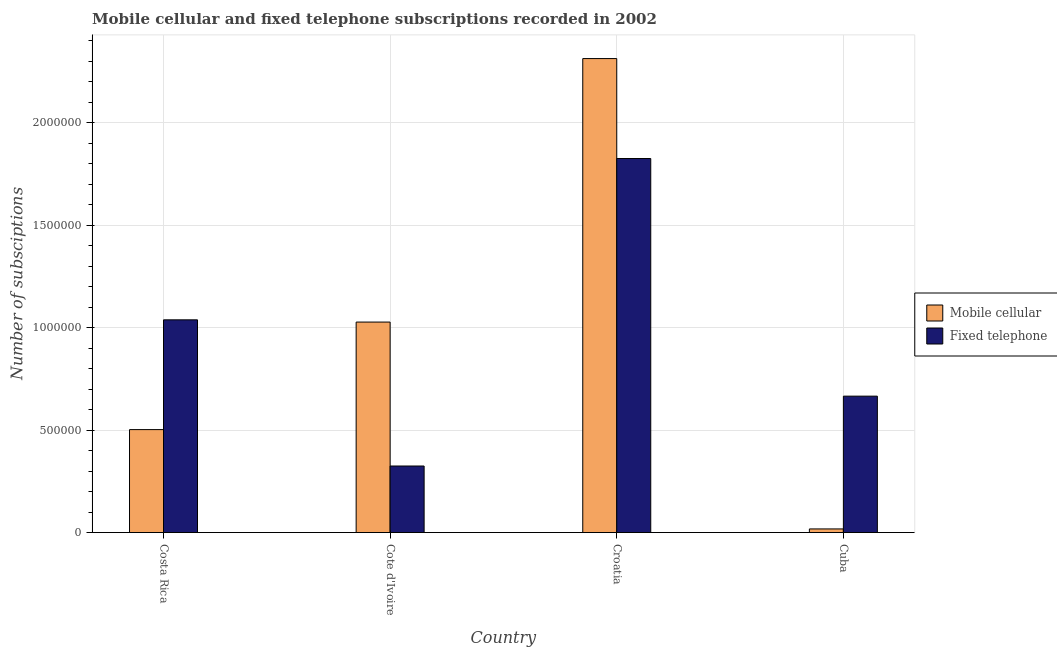How many different coloured bars are there?
Make the answer very short. 2. Are the number of bars per tick equal to the number of legend labels?
Provide a succinct answer. Yes. How many bars are there on the 4th tick from the left?
Offer a very short reply. 2. How many bars are there on the 3rd tick from the right?
Your answer should be very brief. 2. What is the label of the 1st group of bars from the left?
Provide a short and direct response. Costa Rica. In how many cases, is the number of bars for a given country not equal to the number of legend labels?
Offer a terse response. 0. What is the number of mobile cellular subscriptions in Croatia?
Give a very brief answer. 2.31e+06. Across all countries, what is the maximum number of fixed telephone subscriptions?
Provide a succinct answer. 1.82e+06. Across all countries, what is the minimum number of fixed telephone subscriptions?
Provide a short and direct response. 3.25e+05. In which country was the number of fixed telephone subscriptions maximum?
Offer a very short reply. Croatia. In which country was the number of mobile cellular subscriptions minimum?
Make the answer very short. Cuba. What is the total number of mobile cellular subscriptions in the graph?
Ensure brevity in your answer.  3.86e+06. What is the difference between the number of mobile cellular subscriptions in Cote d'Ivoire and that in Cuba?
Ensure brevity in your answer.  1.01e+06. What is the difference between the number of fixed telephone subscriptions in Cuba and the number of mobile cellular subscriptions in Cote d'Ivoire?
Keep it short and to the point. -3.61e+05. What is the average number of fixed telephone subscriptions per country?
Your response must be concise. 9.63e+05. What is the difference between the number of fixed telephone subscriptions and number of mobile cellular subscriptions in Costa Rica?
Give a very brief answer. 5.36e+05. What is the ratio of the number of fixed telephone subscriptions in Costa Rica to that in Croatia?
Your response must be concise. 0.57. Is the number of fixed telephone subscriptions in Costa Rica less than that in Cote d'Ivoire?
Give a very brief answer. No. Is the difference between the number of mobile cellular subscriptions in Cote d'Ivoire and Cuba greater than the difference between the number of fixed telephone subscriptions in Cote d'Ivoire and Cuba?
Your answer should be compact. Yes. What is the difference between the highest and the second highest number of fixed telephone subscriptions?
Give a very brief answer. 7.87e+05. What is the difference between the highest and the lowest number of mobile cellular subscriptions?
Provide a short and direct response. 2.29e+06. What does the 2nd bar from the left in Cote d'Ivoire represents?
Provide a short and direct response. Fixed telephone. What does the 1st bar from the right in Cuba represents?
Give a very brief answer. Fixed telephone. How many countries are there in the graph?
Offer a very short reply. 4. What is the difference between two consecutive major ticks on the Y-axis?
Give a very brief answer. 5.00e+05. Are the values on the major ticks of Y-axis written in scientific E-notation?
Offer a very short reply. No. Does the graph contain grids?
Provide a succinct answer. Yes. How many legend labels are there?
Make the answer very short. 2. How are the legend labels stacked?
Provide a short and direct response. Vertical. What is the title of the graph?
Ensure brevity in your answer.  Mobile cellular and fixed telephone subscriptions recorded in 2002. What is the label or title of the Y-axis?
Offer a terse response. Number of subsciptions. What is the Number of subsciptions in Mobile cellular in Costa Rica?
Your answer should be very brief. 5.02e+05. What is the Number of subsciptions in Fixed telephone in Costa Rica?
Provide a succinct answer. 1.04e+06. What is the Number of subsciptions of Mobile cellular in Cote d'Ivoire?
Keep it short and to the point. 1.03e+06. What is the Number of subsciptions of Fixed telephone in Cote d'Ivoire?
Your answer should be very brief. 3.25e+05. What is the Number of subsciptions in Mobile cellular in Croatia?
Give a very brief answer. 2.31e+06. What is the Number of subsciptions in Fixed telephone in Croatia?
Give a very brief answer. 1.82e+06. What is the Number of subsciptions in Mobile cellular in Cuba?
Provide a succinct answer. 1.79e+04. What is the Number of subsciptions of Fixed telephone in Cuba?
Your answer should be compact. 6.66e+05. Across all countries, what is the maximum Number of subsciptions of Mobile cellular?
Your answer should be very brief. 2.31e+06. Across all countries, what is the maximum Number of subsciptions of Fixed telephone?
Your answer should be compact. 1.82e+06. Across all countries, what is the minimum Number of subsciptions of Mobile cellular?
Your answer should be very brief. 1.79e+04. Across all countries, what is the minimum Number of subsciptions in Fixed telephone?
Your answer should be very brief. 3.25e+05. What is the total Number of subsciptions of Mobile cellular in the graph?
Provide a succinct answer. 3.86e+06. What is the total Number of subsciptions of Fixed telephone in the graph?
Give a very brief answer. 3.85e+06. What is the difference between the Number of subsciptions in Mobile cellular in Costa Rica and that in Cote d'Ivoire?
Your answer should be very brief. -5.25e+05. What is the difference between the Number of subsciptions of Fixed telephone in Costa Rica and that in Cote d'Ivoire?
Provide a succinct answer. 7.13e+05. What is the difference between the Number of subsciptions of Mobile cellular in Costa Rica and that in Croatia?
Your response must be concise. -1.81e+06. What is the difference between the Number of subsciptions of Fixed telephone in Costa Rica and that in Croatia?
Provide a succinct answer. -7.87e+05. What is the difference between the Number of subsciptions in Mobile cellular in Costa Rica and that in Cuba?
Make the answer very short. 4.85e+05. What is the difference between the Number of subsciptions of Fixed telephone in Costa Rica and that in Cuba?
Make the answer very short. 3.72e+05. What is the difference between the Number of subsciptions of Mobile cellular in Cote d'Ivoire and that in Croatia?
Make the answer very short. -1.29e+06. What is the difference between the Number of subsciptions of Fixed telephone in Cote d'Ivoire and that in Croatia?
Keep it short and to the point. -1.50e+06. What is the difference between the Number of subsciptions in Mobile cellular in Cote d'Ivoire and that in Cuba?
Your response must be concise. 1.01e+06. What is the difference between the Number of subsciptions of Fixed telephone in Cote d'Ivoire and that in Cuba?
Offer a very short reply. -3.41e+05. What is the difference between the Number of subsciptions of Mobile cellular in Croatia and that in Cuba?
Offer a terse response. 2.29e+06. What is the difference between the Number of subsciptions of Fixed telephone in Croatia and that in Cuba?
Offer a terse response. 1.16e+06. What is the difference between the Number of subsciptions in Mobile cellular in Costa Rica and the Number of subsciptions in Fixed telephone in Cote d'Ivoire?
Offer a terse response. 1.78e+05. What is the difference between the Number of subsciptions of Mobile cellular in Costa Rica and the Number of subsciptions of Fixed telephone in Croatia?
Your response must be concise. -1.32e+06. What is the difference between the Number of subsciptions in Mobile cellular in Costa Rica and the Number of subsciptions in Fixed telephone in Cuba?
Offer a very short reply. -1.63e+05. What is the difference between the Number of subsciptions of Mobile cellular in Cote d'Ivoire and the Number of subsciptions of Fixed telephone in Croatia?
Ensure brevity in your answer.  -7.98e+05. What is the difference between the Number of subsciptions of Mobile cellular in Cote d'Ivoire and the Number of subsciptions of Fixed telephone in Cuba?
Your response must be concise. 3.61e+05. What is the difference between the Number of subsciptions in Mobile cellular in Croatia and the Number of subsciptions in Fixed telephone in Cuba?
Your answer should be very brief. 1.65e+06. What is the average Number of subsciptions in Mobile cellular per country?
Give a very brief answer. 9.65e+05. What is the average Number of subsciptions of Fixed telephone per country?
Provide a short and direct response. 9.63e+05. What is the difference between the Number of subsciptions of Mobile cellular and Number of subsciptions of Fixed telephone in Costa Rica?
Ensure brevity in your answer.  -5.36e+05. What is the difference between the Number of subsciptions in Mobile cellular and Number of subsciptions in Fixed telephone in Cote d'Ivoire?
Offer a very short reply. 7.02e+05. What is the difference between the Number of subsciptions in Mobile cellular and Number of subsciptions in Fixed telephone in Croatia?
Keep it short and to the point. 4.88e+05. What is the difference between the Number of subsciptions of Mobile cellular and Number of subsciptions of Fixed telephone in Cuba?
Your response must be concise. -6.48e+05. What is the ratio of the Number of subsciptions of Mobile cellular in Costa Rica to that in Cote d'Ivoire?
Your response must be concise. 0.49. What is the ratio of the Number of subsciptions in Fixed telephone in Costa Rica to that in Cote d'Ivoire?
Ensure brevity in your answer.  3.2. What is the ratio of the Number of subsciptions in Mobile cellular in Costa Rica to that in Croatia?
Give a very brief answer. 0.22. What is the ratio of the Number of subsciptions in Fixed telephone in Costa Rica to that in Croatia?
Provide a succinct answer. 0.57. What is the ratio of the Number of subsciptions in Mobile cellular in Costa Rica to that in Cuba?
Keep it short and to the point. 28.15. What is the ratio of the Number of subsciptions in Fixed telephone in Costa Rica to that in Cuba?
Make the answer very short. 1.56. What is the ratio of the Number of subsciptions of Mobile cellular in Cote d'Ivoire to that in Croatia?
Your answer should be compact. 0.44. What is the ratio of the Number of subsciptions of Fixed telephone in Cote d'Ivoire to that in Croatia?
Ensure brevity in your answer.  0.18. What is the ratio of the Number of subsciptions of Mobile cellular in Cote d'Ivoire to that in Cuba?
Your answer should be compact. 57.53. What is the ratio of the Number of subsciptions of Fixed telephone in Cote d'Ivoire to that in Cuba?
Ensure brevity in your answer.  0.49. What is the ratio of the Number of subsciptions of Mobile cellular in Croatia to that in Cuba?
Make the answer very short. 129.55. What is the ratio of the Number of subsciptions of Fixed telephone in Croatia to that in Cuba?
Your response must be concise. 2.74. What is the difference between the highest and the second highest Number of subsciptions in Mobile cellular?
Offer a very short reply. 1.29e+06. What is the difference between the highest and the second highest Number of subsciptions of Fixed telephone?
Your answer should be compact. 7.87e+05. What is the difference between the highest and the lowest Number of subsciptions of Mobile cellular?
Your response must be concise. 2.29e+06. What is the difference between the highest and the lowest Number of subsciptions in Fixed telephone?
Your answer should be compact. 1.50e+06. 